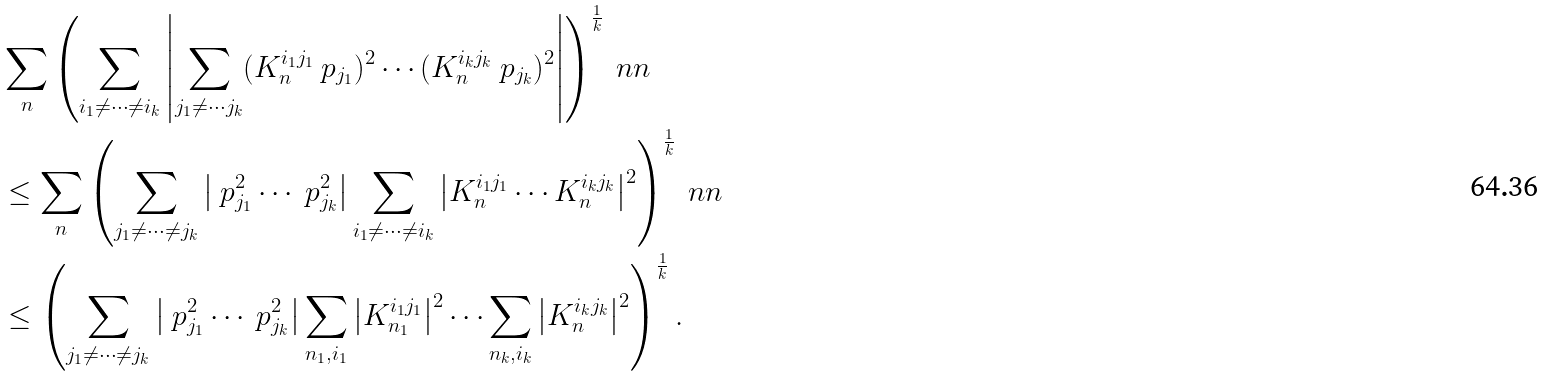Convert formula to latex. <formula><loc_0><loc_0><loc_500><loc_500>& \sum _ { n } \left ( \sum _ { i _ { 1 } \neq \cdots \neq i _ { k } } \left | \sum _ { j _ { 1 } \neq \cdots j _ { k } } ( K _ { n } ^ { i _ { 1 } j _ { 1 } } \ p _ { j _ { 1 } } ) ^ { 2 } \cdots ( K _ { n } ^ { i _ { k } j _ { k } } \ p _ { j _ { k } } ) ^ { 2 } \right | \right ) ^ { \frac { 1 } { k } } \ n n \\ & \leq \sum _ { n } \left ( \sum _ { j _ { 1 } \neq \cdots \neq j _ { k } } \left | \ p _ { j _ { 1 } } ^ { 2 } \cdots \ p _ { j _ { k } } ^ { 2 } \right | \sum _ { i _ { 1 } \neq \cdots \neq i _ { k } } \left | K _ { n } ^ { i _ { 1 } j _ { 1 } } \cdots K _ { n } ^ { i _ { k } j _ { k } } \right | ^ { 2 } \right ) ^ { \frac { 1 } { k } } \ n n \\ & \leq \left ( \sum _ { j _ { 1 } \neq \cdots \neq j _ { k } } \left | \ p _ { j _ { 1 } } ^ { 2 } \cdots \ p _ { j _ { k } } ^ { 2 } \right | \sum _ { n _ { 1 } , i _ { 1 } } \left | K _ { n _ { 1 } } ^ { i _ { 1 } j _ { 1 } } \right | ^ { 2 } \cdots \sum _ { n _ { k } , i _ { k } } \left | K _ { n } ^ { i _ { k } j _ { k } } \right | ^ { 2 } \right ) ^ { \frac { 1 } { k } } .</formula> 